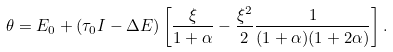Convert formula to latex. <formula><loc_0><loc_0><loc_500><loc_500>\theta = E _ { 0 } + ( \tau _ { 0 } I - \Delta E ) \left [ \frac { \xi } { 1 + \alpha } - \frac { \xi ^ { 2 } } { 2 } \frac { 1 } { ( 1 + \alpha ) ( 1 + 2 \alpha ) } \right ] .</formula> 